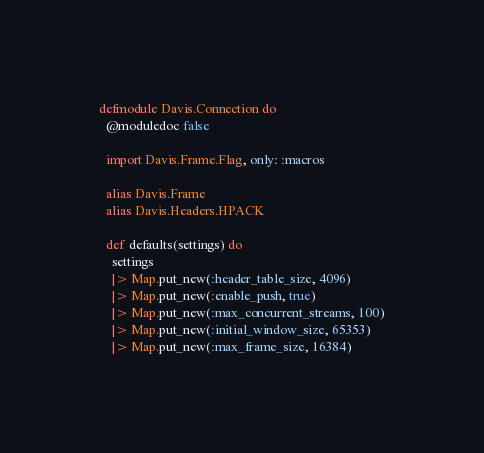Convert code to text. <code><loc_0><loc_0><loc_500><loc_500><_Elixir_>defmodule Davis.Connection do
  @moduledoc false

  import Davis.Frame.Flag, only: :macros

  alias Davis.Frame
  alias Davis.Headers.HPACK

  def defaults(settings) do
    settings
    |> Map.put_new(:header_table_size, 4096)
    |> Map.put_new(:enable_push, true)
    |> Map.put_new(:max_concurrent_streams, 100)
    |> Map.put_new(:initial_window_size, 65353)
    |> Map.put_new(:max_frame_size, 16384)</code> 